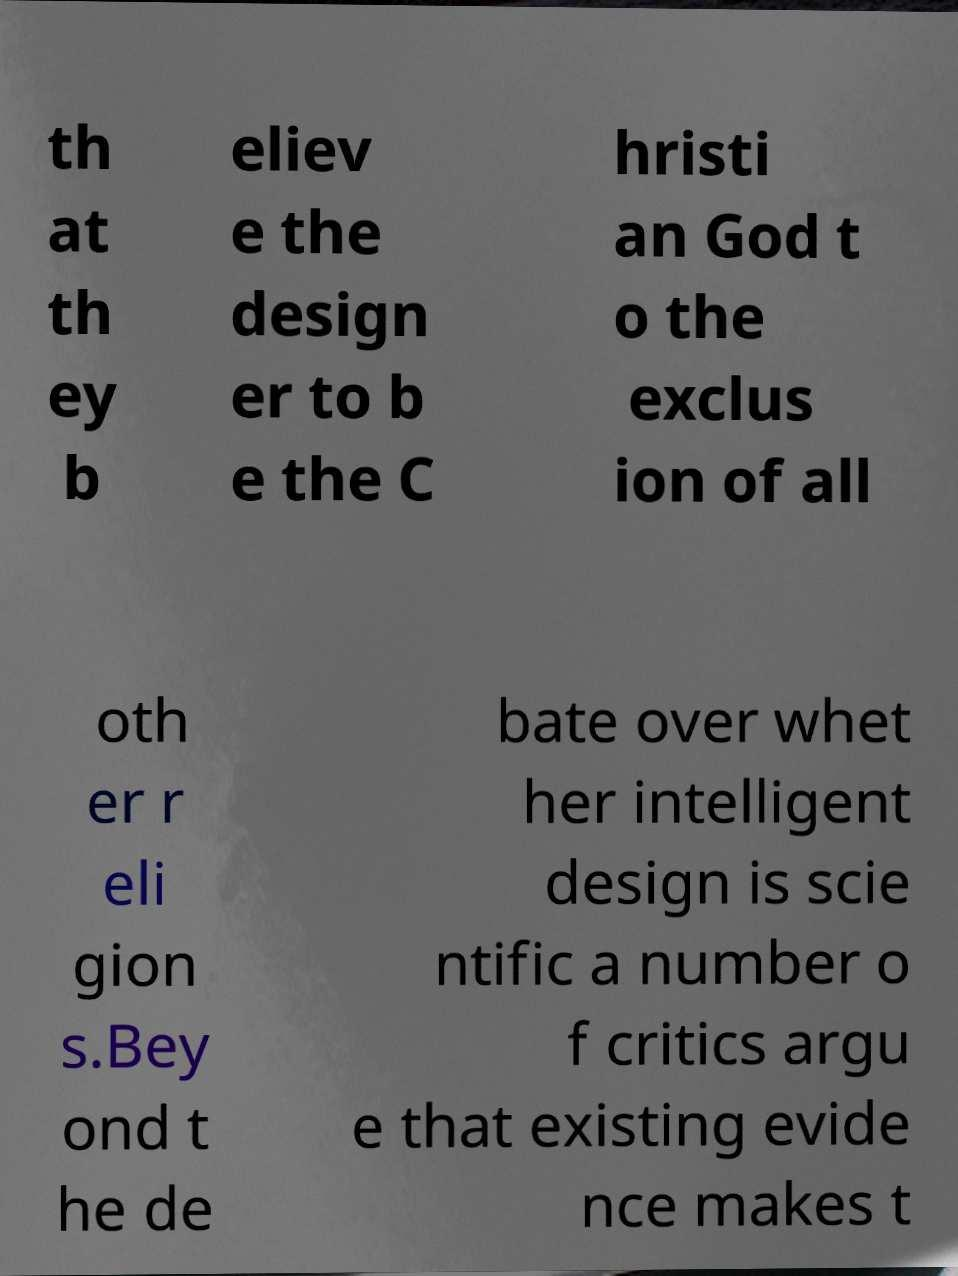Could you assist in decoding the text presented in this image and type it out clearly? th at th ey b eliev e the design er to b e the C hristi an God t o the exclus ion of all oth er r eli gion s.Bey ond t he de bate over whet her intelligent design is scie ntific a number o f critics argu e that existing evide nce makes t 